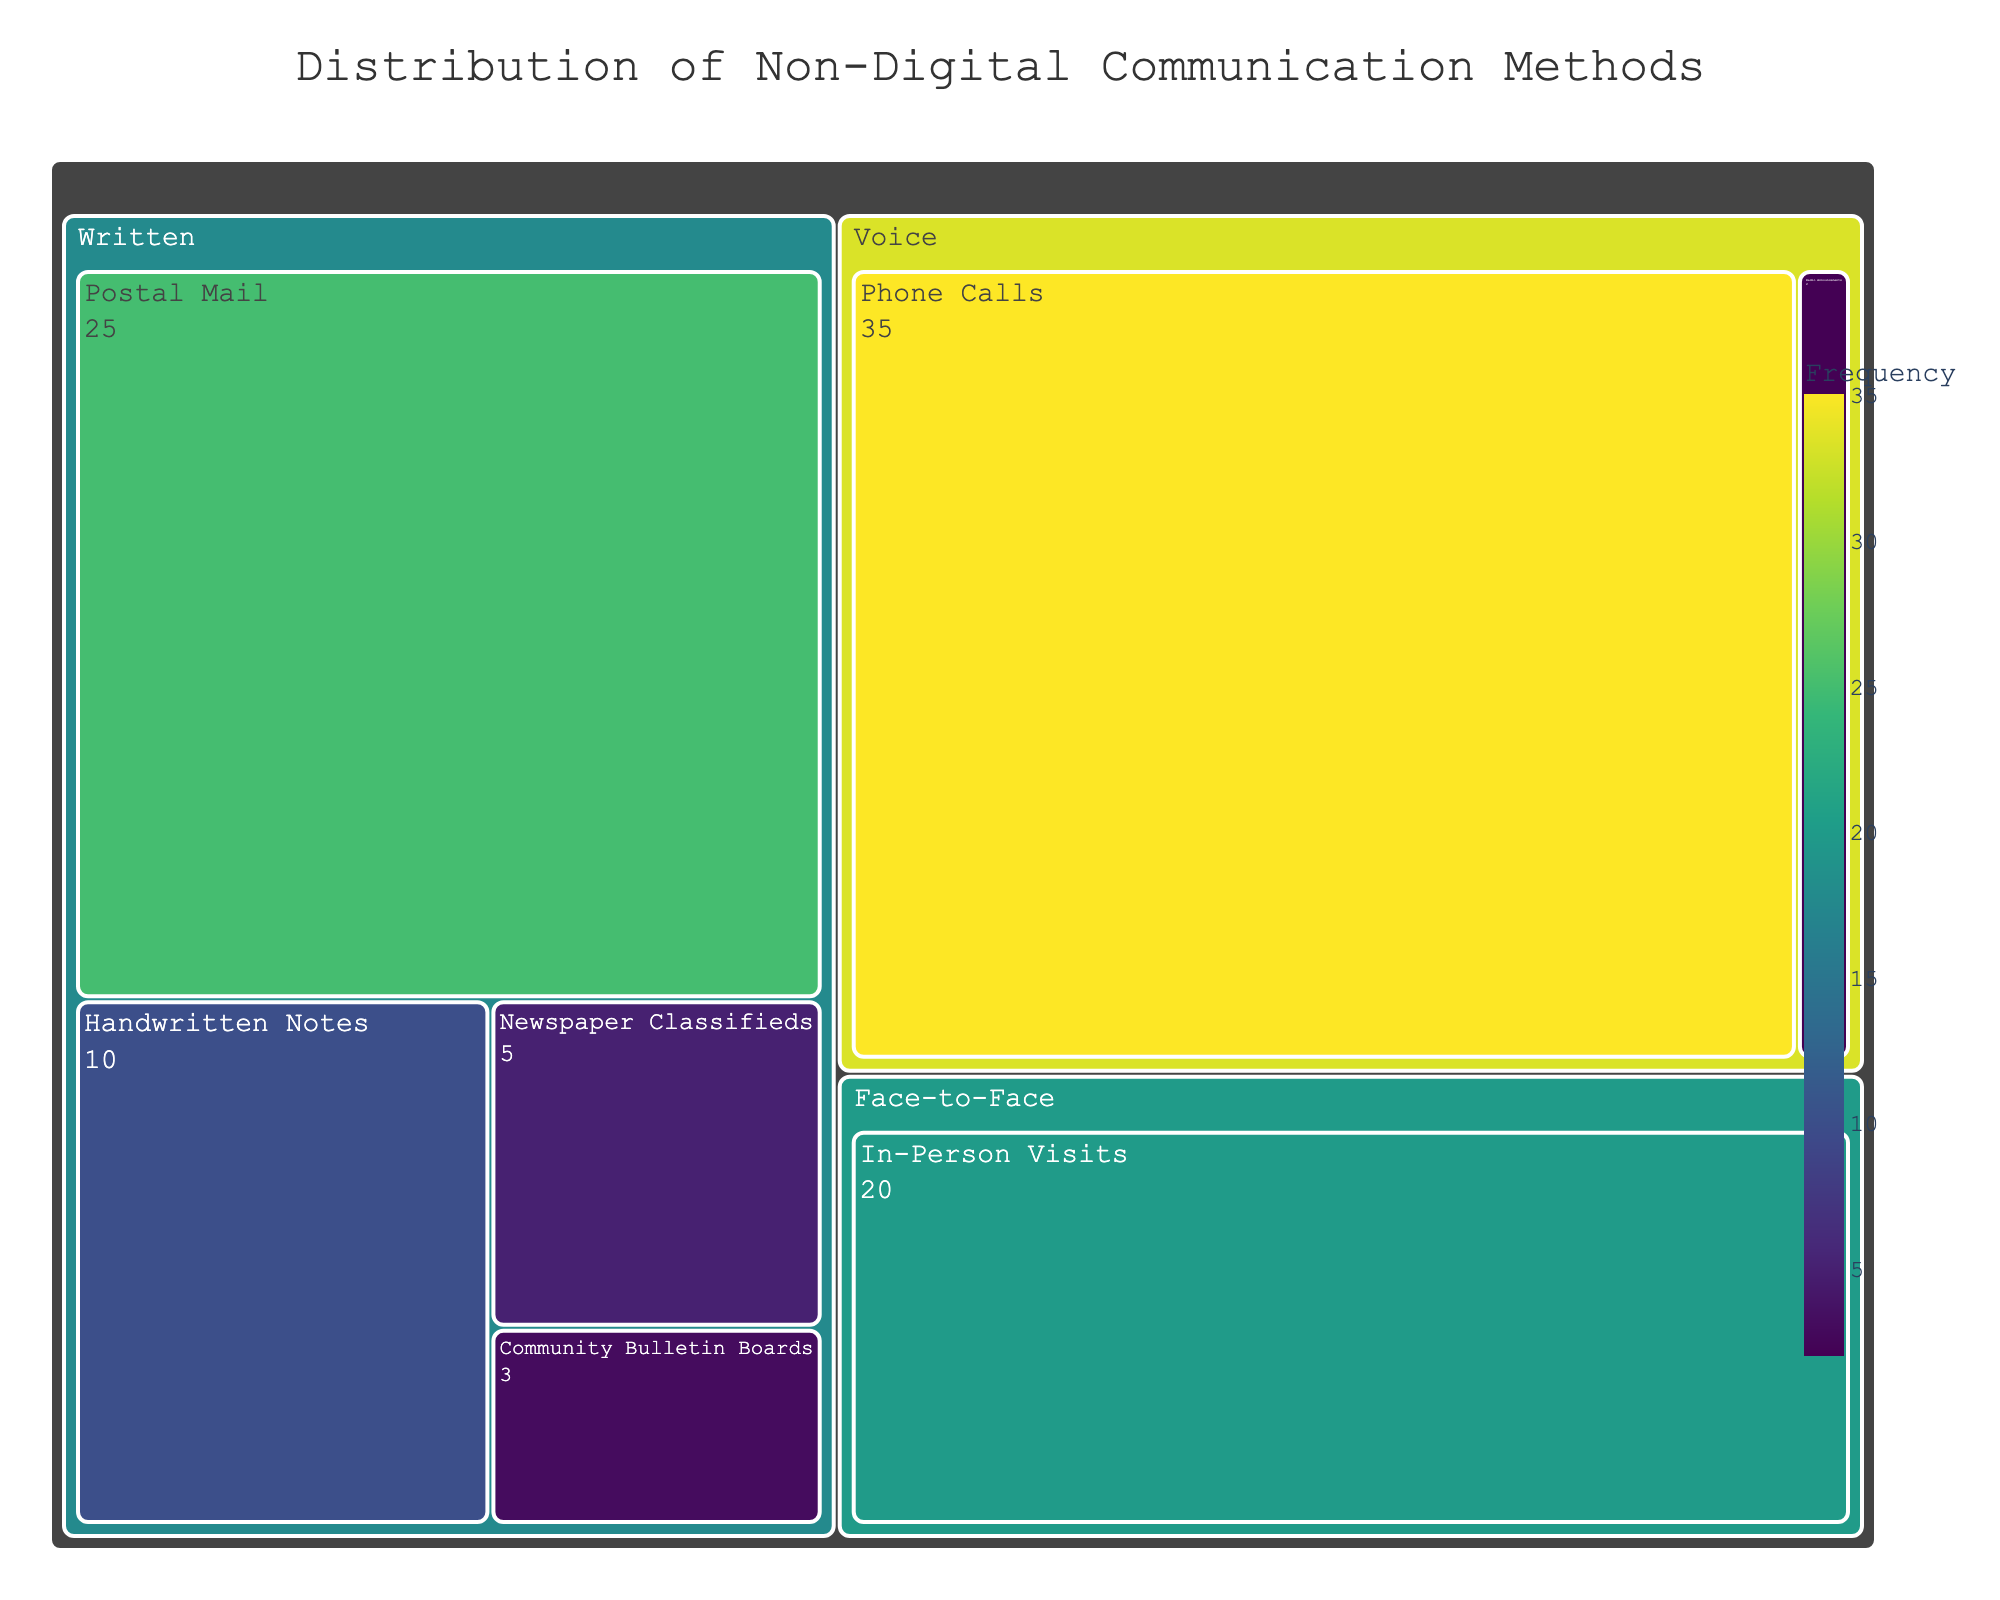What's the title of the figure? The title is located at the top center part of the figure, where the larger and bold text is displayed. In this case, it reads "Distribution of Non-Digital Communication Methods".
Answer: Distribution of Non-Digital Communication Methods How many communication methods are shown under the 'Written' category? Look at the Written section in the treemap and count all unique communication method labels listed within it.
Answer: 5 Which communication method has the highest frequency? Find the largest segment in the treemap that contains the highest frequency value for its label. It's the communication method with the most area.
Answer: Phone Calls What is the combined frequency of all Written communication methods? Add the frequency values of all the communication methods under the Written category. These are 25 (Postal Mail), 10 (Handwritten Notes), 5 (Newspaper Classifieds), and 3 (Community Bulletin Boards).
Answer: 43 Which type of communication method has a larger total frequency, Voice or Face-to-Face? Sum the frequencies of communication methods under the Voice type (Phone Calls: 35, Radio Announcements: 2) and compare with the frequency under Face-to-Face (In-Person Visits: 20).
Answer: Voice How does the frequency of Handwritten Notes compare to Newspaper Classifieds? Locate Handwritten Notes and Newspaper Classifieds in the treemap and compare their labeled frequency values.
Answer: Handwritten Notes have a higher frequency What is the difference in frequency between the highest and lowest communication methods? Identify the highest frequency value (Phone Calls: 35) and the lowest frequency value (Radio Announcements: 2), then calculate the difference.
Answer: 33 Which communication method under the Written category has the lowest frequency? Locate all methods under the Written category and pick the one with the smallest frequency value.
Answer: Community Bulletin Boards What is the overall distribution pattern among the different communication types? Observe the relative sizes and areas of each type's segment in the treemap, identifying which types have larger or smaller total frequencies.
Answer: Voice has the largest, followed by Written, then Face-to-Face What frequency is associated with Radio Announcements and how does it rank in size within the Voice category? Find the frequency value for Radio Announcements and compare it relative to other methods within the Voice category, which includes Phone Calls.
Answer: 2, second largest within Voice 